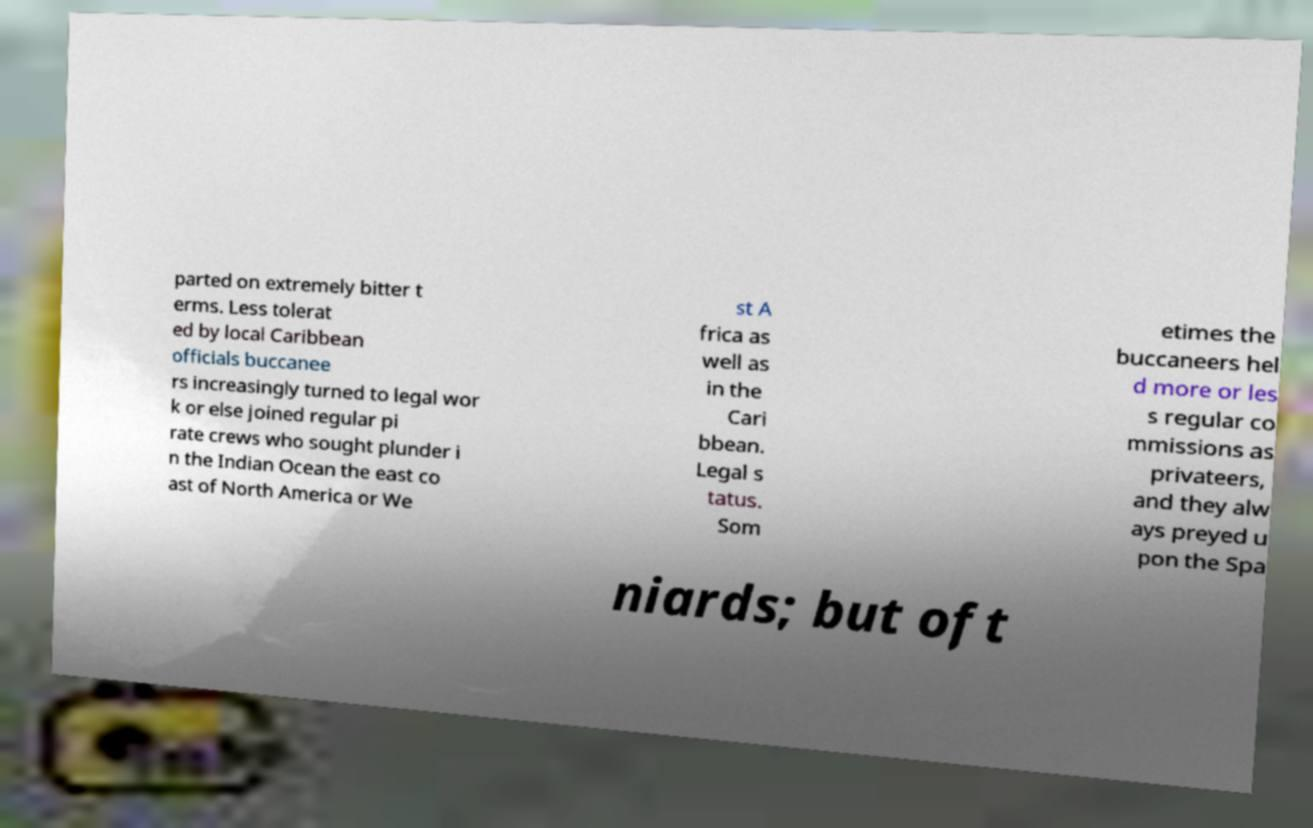I need the written content from this picture converted into text. Can you do that? parted on extremely bitter t erms. Less tolerat ed by local Caribbean officials buccanee rs increasingly turned to legal wor k or else joined regular pi rate crews who sought plunder i n the Indian Ocean the east co ast of North America or We st A frica as well as in the Cari bbean. Legal s tatus. Som etimes the buccaneers hel d more or les s regular co mmissions as privateers, and they alw ays preyed u pon the Spa niards; but oft 